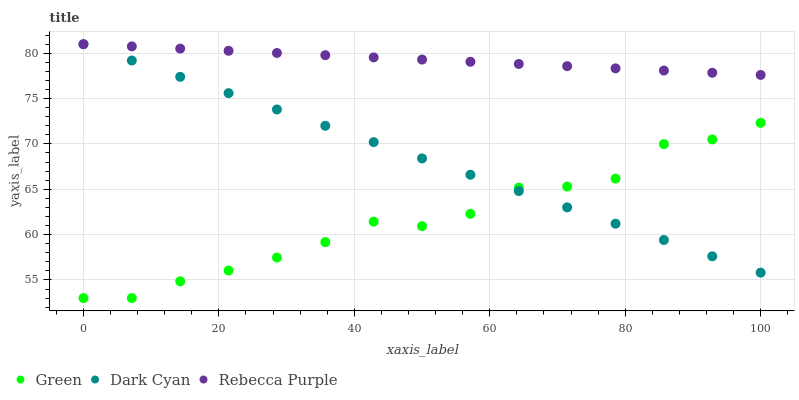Does Green have the minimum area under the curve?
Answer yes or no. Yes. Does Rebecca Purple have the maximum area under the curve?
Answer yes or no. Yes. Does Rebecca Purple have the minimum area under the curve?
Answer yes or no. No. Does Green have the maximum area under the curve?
Answer yes or no. No. Is Dark Cyan the smoothest?
Answer yes or no. Yes. Is Green the roughest?
Answer yes or no. Yes. Is Rebecca Purple the smoothest?
Answer yes or no. No. Is Rebecca Purple the roughest?
Answer yes or no. No. Does Green have the lowest value?
Answer yes or no. Yes. Does Rebecca Purple have the lowest value?
Answer yes or no. No. Does Rebecca Purple have the highest value?
Answer yes or no. Yes. Does Green have the highest value?
Answer yes or no. No. Is Green less than Rebecca Purple?
Answer yes or no. Yes. Is Rebecca Purple greater than Green?
Answer yes or no. Yes. Does Rebecca Purple intersect Dark Cyan?
Answer yes or no. Yes. Is Rebecca Purple less than Dark Cyan?
Answer yes or no. No. Is Rebecca Purple greater than Dark Cyan?
Answer yes or no. No. Does Green intersect Rebecca Purple?
Answer yes or no. No. 